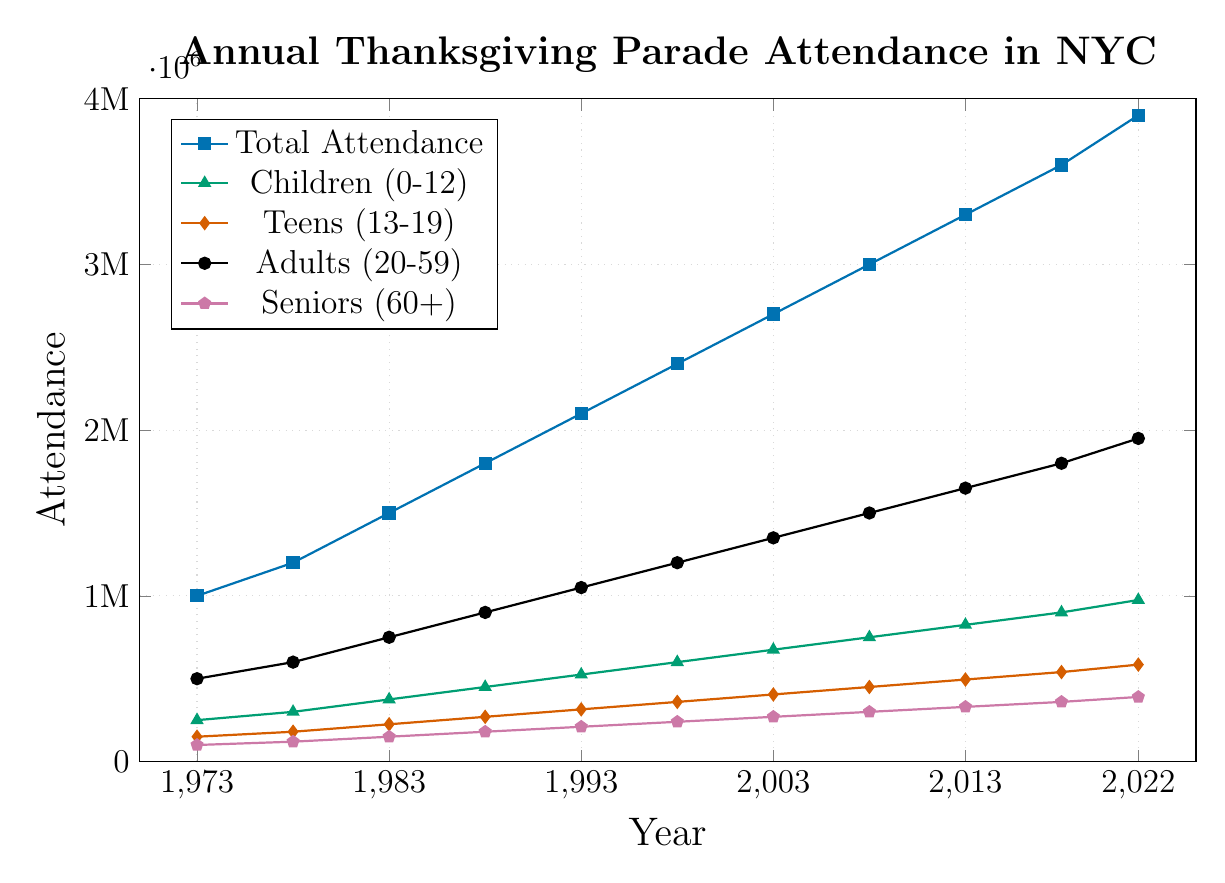Which age group had the smallest attendance in 2022? By looking at the end point of each line in 2022, we can identify that the line with the lowest value corresponds to the Seniors (60+) group.
Answer: Seniors (60+) Between 1973 and 2022, which age group's attendance increased the most? To determine this, subtract the 1973 attendance from the 2022 attendance for each age group: Children (975,000 - 250,000 = 725,000), Teens (585,000 - 150,000 = 435,000), Adults (1,950,000 - 500,000 = 1,450,000), Seniors (390,000 - 100,000 = 290,000). The Adults group had the highest increase.
Answer: Adults (20-59) What was the average attendance of Children (0-12) for the years provided? Sum the attendances for Children (0-12) over the years and divide by the number of years: (250,000 + 300,000 + 375,000 + 450,000 + 525,000 + 600,000 + 675,000 + 750,000 + 825,000 + 900,000 + 975,000) / 11 = 592,500.
Answer: 592,500 Which age group had the most consistent growth over the years? By visually inspecting the slope of the lines, the Adults (20-59) group shows a steady, consistent increase without much fluctuation.
Answer: Adults (20-59) What is the total attendance in 1988 and how does it compare to 2018? The total attendance in 1988 was 1,800,000 and in 2018 it was 3,600,000. To compare, 3,600,000 - 1,800,000 = 1,800,000 increase.
Answer: 1,800,000 increase In which year did the Teens (13-19) group have an attendance of 450,000? By finding the point on the Teens line that has an attendance of 450,000, we can see it occurs in 2008.
Answer: 2008 Which year's total attendance first reached above 1,000,000? The plot shows that the total attendance first reached above 1,000,000 in the year 1973.
Answer: 1973 Among children and seniors, whose attendance growth from 1973 to 2013 was steeper? Calculating the slope for each: Children (825,000 - 250,000) / (2013 - 1973) = 575,000 / 40 = 14,375 per year. Seniors (330,000 - 100,000) / (2013 - 1973) = 230,000 / 40 = 5,750 per year. Children's attendance grew steeper.
Answer: Children (0-12) Which age group had more than double the attendance in 2022 compared to 1988? Calculate double the 1988 attendance and compare it to 2022 for each group: Children (450,000 * 2 = 900,000; 2022 = 975,000), Teens (270,000 * 2 = 540,000; 2022 = 585,000), Adults (900,000 * 2 = 1,800,000; 2022 = 1,950,000), Seniors (180,000 * 2 = 360,000; 2022 = 390,000). All groups have more than doubled except Seniors.
Answer: Children, Teens, Adults 